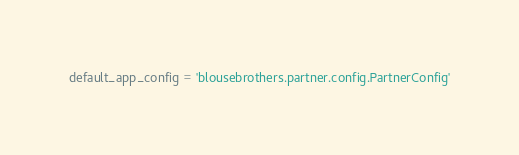<code> <loc_0><loc_0><loc_500><loc_500><_Python_>default_app_config = 'blousebrothers.partner.config.PartnerConfig'
</code> 